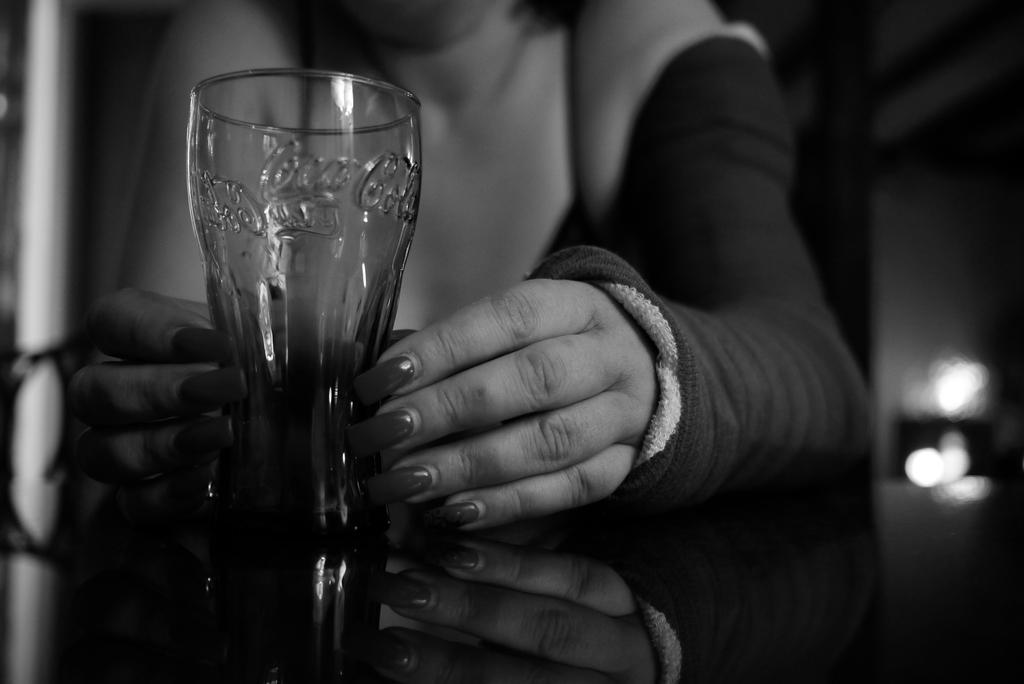What is the color scheme of the image? The image is black and white. Can you describe the person in the image? There is a woman in the image. What is the woman holding in the image? The woman is holding a glass. What type of slope can be seen in the background of the image? There is no slope visible in the image, as it is a black and white image featuring a woman holding a glass. 